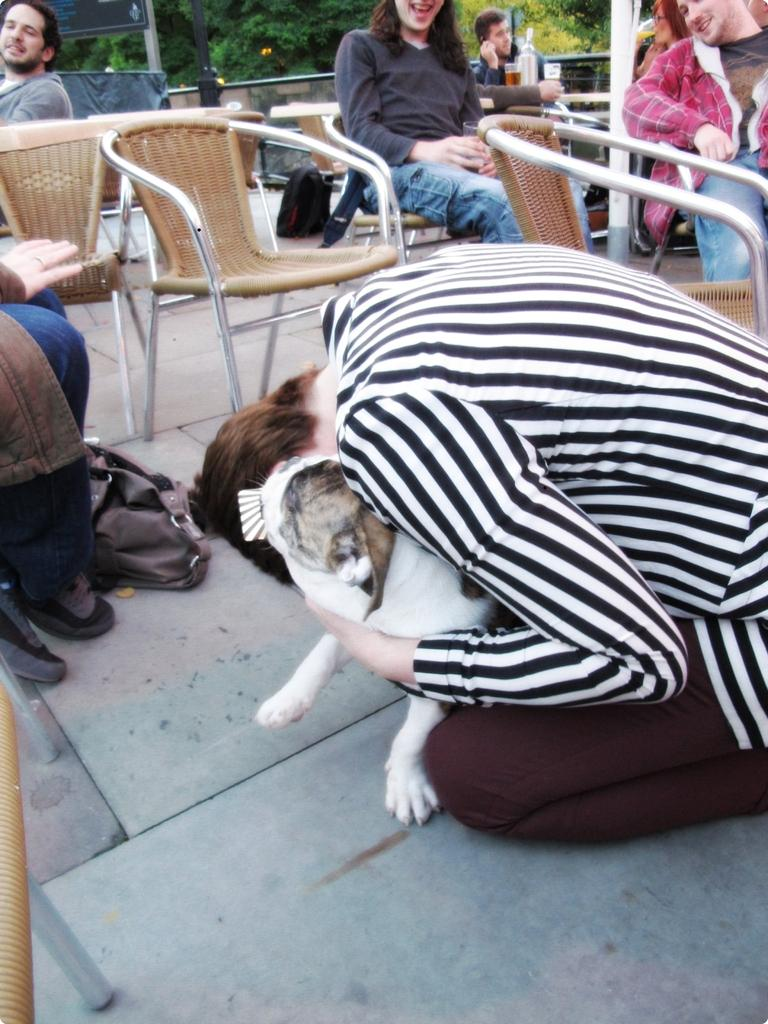What is the main subject of the image? The main subject of the image is a group of people. How are the people in the image positioned? The group of people are sitting on a chair. Can you describe the woman in the image? The woman in the image is sitting on the ground. What is the woman holding in the image? The woman is holding a dog. How many chickens are present in the image? There are no chickens present in the image. What story is the woman telling the dog in the image? The image does not depict the woman telling a story to the dog; it only shows her holding the dog. 